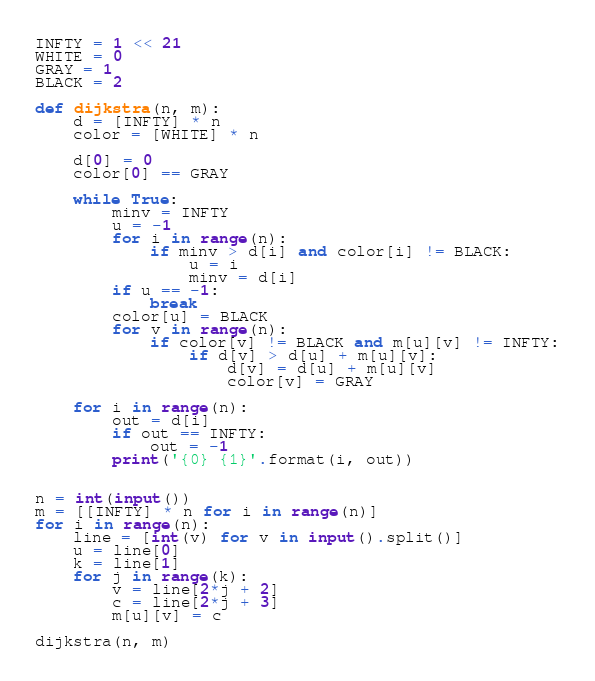<code> <loc_0><loc_0><loc_500><loc_500><_Python_>INFTY = 1 << 21
WHITE = 0
GRAY = 1
BLACK = 2

def dijkstra(n, m):
    d = [INFTY] * n
    color = [WHITE] * n

    d[0] = 0
    color[0] == GRAY

    while True:
        minv = INFTY
        u = -1
        for i in range(n):
            if minv > d[i] and color[i] != BLACK:
                u = i
                minv = d[i]
        if u == -1:
            break
        color[u] = BLACK
        for v in range(n):
            if color[v] != BLACK and m[u][v] != INFTY:
                if d[v] > d[u] + m[u][v]:
                    d[v] = d[u] + m[u][v]
                    color[v] = GRAY

    for i in range(n):
        out = d[i]
        if out == INFTY:
            out = -1
        print('{0} {1}'.format(i, out))


n = int(input())
m = [[INFTY] * n for i in range(n)]
for i in range(n):
    line = [int(v) for v in input().split()]
    u = line[0]
    k = line[1]
    for j in range(k):
        v = line[2*j + 2]
        c = line[2*j + 3]
        m[u][v] = c

dijkstra(n, m)
</code> 